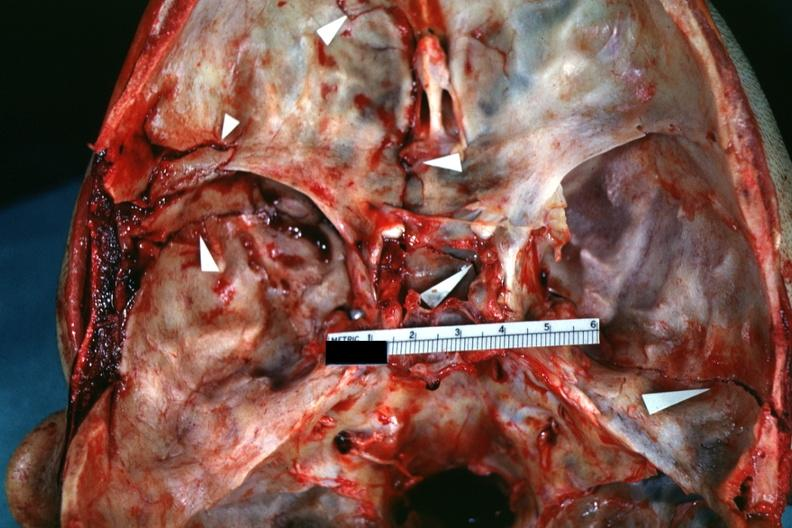s focal hemorrhagic infarction well shown present?
Answer the question using a single word or phrase. No 